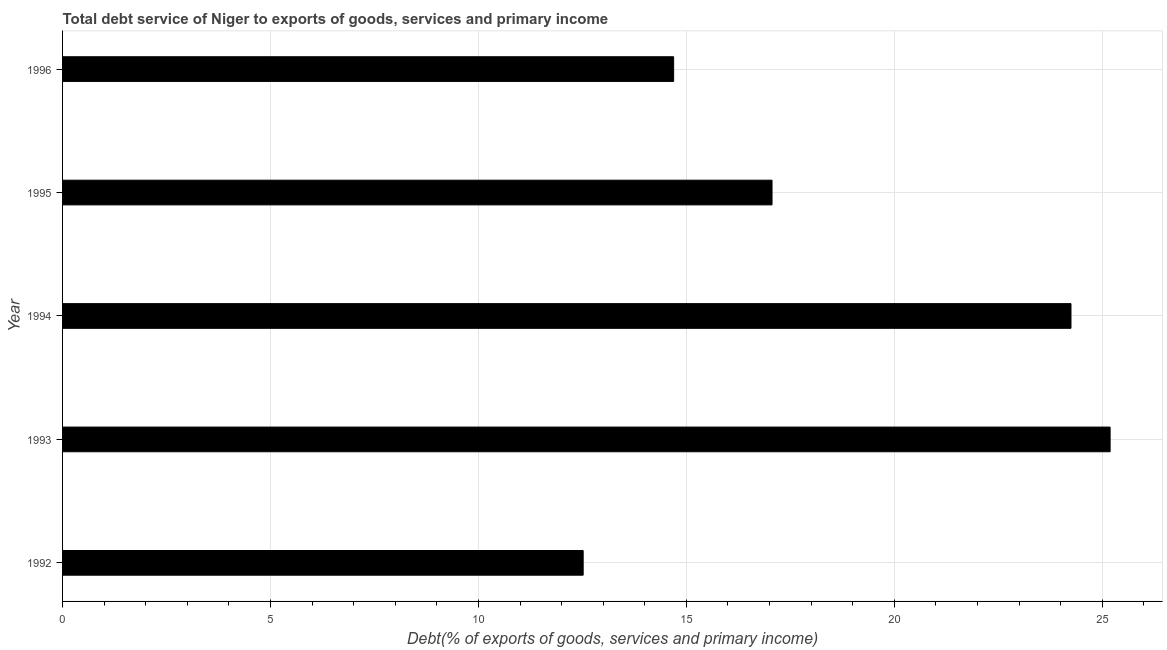Does the graph contain any zero values?
Ensure brevity in your answer.  No. Does the graph contain grids?
Provide a succinct answer. Yes. What is the title of the graph?
Provide a succinct answer. Total debt service of Niger to exports of goods, services and primary income. What is the label or title of the X-axis?
Your answer should be compact. Debt(% of exports of goods, services and primary income). What is the label or title of the Y-axis?
Your response must be concise. Year. What is the total debt service in 1996?
Your response must be concise. 14.69. Across all years, what is the maximum total debt service?
Offer a terse response. 25.19. Across all years, what is the minimum total debt service?
Offer a very short reply. 12.52. What is the sum of the total debt service?
Make the answer very short. 93.72. What is the difference between the total debt service in 1993 and 1995?
Keep it short and to the point. 8.13. What is the average total debt service per year?
Your answer should be very brief. 18.74. What is the median total debt service?
Offer a very short reply. 17.06. What is the ratio of the total debt service in 1995 to that in 1996?
Your response must be concise. 1.16. Is the total debt service in 1995 less than that in 1996?
Ensure brevity in your answer.  No. Is the difference between the total debt service in 1993 and 1996 greater than the difference between any two years?
Your answer should be very brief. No. What is the difference between the highest and the second highest total debt service?
Give a very brief answer. 0.94. Is the sum of the total debt service in 1992 and 1994 greater than the maximum total debt service across all years?
Make the answer very short. Yes. What is the difference between the highest and the lowest total debt service?
Your answer should be very brief. 12.67. Are all the bars in the graph horizontal?
Give a very brief answer. Yes. What is the difference between two consecutive major ticks on the X-axis?
Make the answer very short. 5. Are the values on the major ticks of X-axis written in scientific E-notation?
Keep it short and to the point. No. What is the Debt(% of exports of goods, services and primary income) in 1992?
Provide a short and direct response. 12.52. What is the Debt(% of exports of goods, services and primary income) of 1993?
Give a very brief answer. 25.19. What is the Debt(% of exports of goods, services and primary income) of 1994?
Your answer should be compact. 24.25. What is the Debt(% of exports of goods, services and primary income) in 1995?
Keep it short and to the point. 17.06. What is the Debt(% of exports of goods, services and primary income) in 1996?
Your answer should be compact. 14.69. What is the difference between the Debt(% of exports of goods, services and primary income) in 1992 and 1993?
Provide a succinct answer. -12.67. What is the difference between the Debt(% of exports of goods, services and primary income) in 1992 and 1994?
Keep it short and to the point. -11.73. What is the difference between the Debt(% of exports of goods, services and primary income) in 1992 and 1995?
Offer a very short reply. -4.54. What is the difference between the Debt(% of exports of goods, services and primary income) in 1992 and 1996?
Ensure brevity in your answer.  -2.18. What is the difference between the Debt(% of exports of goods, services and primary income) in 1993 and 1994?
Give a very brief answer. 0.94. What is the difference between the Debt(% of exports of goods, services and primary income) in 1993 and 1995?
Ensure brevity in your answer.  8.13. What is the difference between the Debt(% of exports of goods, services and primary income) in 1993 and 1996?
Your answer should be very brief. 10.5. What is the difference between the Debt(% of exports of goods, services and primary income) in 1994 and 1995?
Your answer should be very brief. 7.19. What is the difference between the Debt(% of exports of goods, services and primary income) in 1994 and 1996?
Keep it short and to the point. 9.55. What is the difference between the Debt(% of exports of goods, services and primary income) in 1995 and 1996?
Your answer should be compact. 2.37. What is the ratio of the Debt(% of exports of goods, services and primary income) in 1992 to that in 1993?
Your answer should be compact. 0.5. What is the ratio of the Debt(% of exports of goods, services and primary income) in 1992 to that in 1994?
Make the answer very short. 0.52. What is the ratio of the Debt(% of exports of goods, services and primary income) in 1992 to that in 1995?
Give a very brief answer. 0.73. What is the ratio of the Debt(% of exports of goods, services and primary income) in 1992 to that in 1996?
Your answer should be very brief. 0.85. What is the ratio of the Debt(% of exports of goods, services and primary income) in 1993 to that in 1994?
Offer a terse response. 1.04. What is the ratio of the Debt(% of exports of goods, services and primary income) in 1993 to that in 1995?
Offer a terse response. 1.48. What is the ratio of the Debt(% of exports of goods, services and primary income) in 1993 to that in 1996?
Offer a very short reply. 1.71. What is the ratio of the Debt(% of exports of goods, services and primary income) in 1994 to that in 1995?
Offer a very short reply. 1.42. What is the ratio of the Debt(% of exports of goods, services and primary income) in 1994 to that in 1996?
Offer a terse response. 1.65. What is the ratio of the Debt(% of exports of goods, services and primary income) in 1995 to that in 1996?
Ensure brevity in your answer.  1.16. 